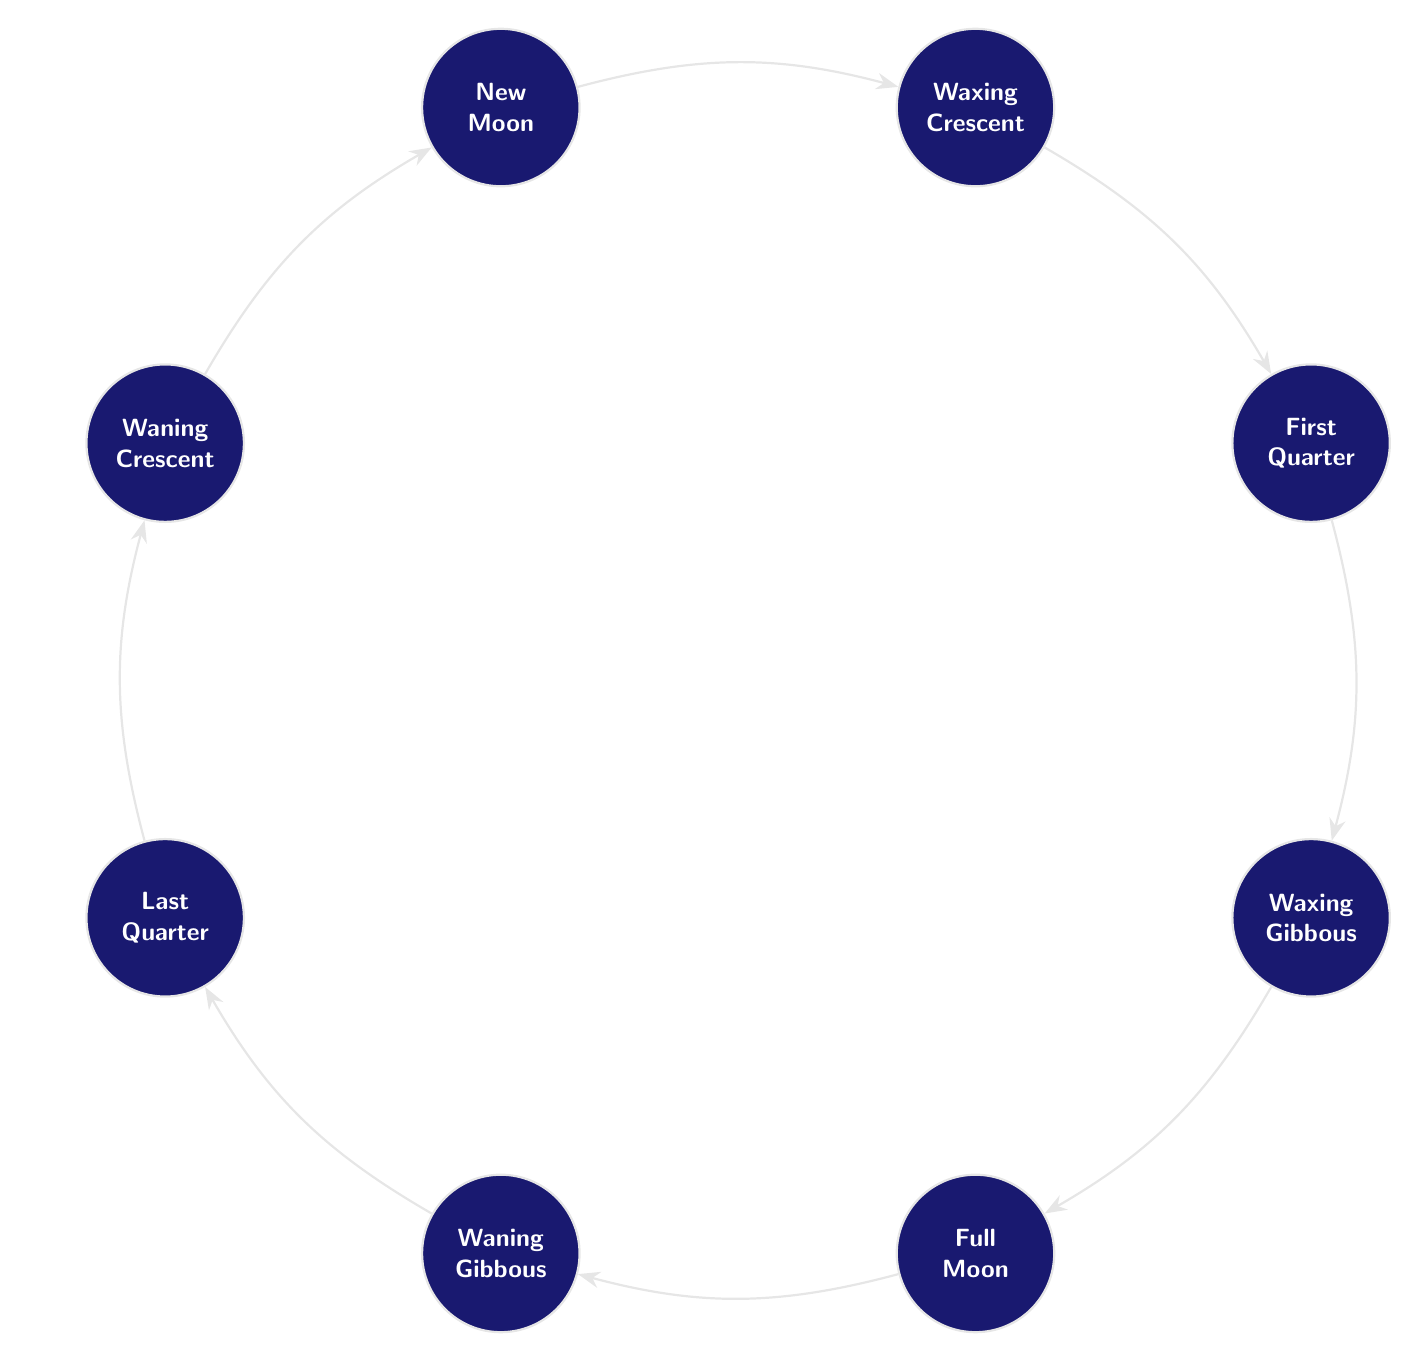What are the names of the phases of the moon shown in the diagram? The diagram displays several phases of the moon including New Moon, Waxing Crescent, First Quarter, Waxing Gibbous, Full Moon, Waning Gibbous, Last Quarter, and Waning Crescent.
Answer: New Moon, Waxing Crescent, First Quarter, Waxing Gibbous, Full Moon, Waning Gibbous, Last Quarter, Waning Crescent How many phases of the moon are represented in the diagram? There are eight distinct phases of the moon represented in the diagram: New Moon, Waxing Crescent, First Quarter, Waxing Gibbous, Full Moon, Waning Gibbous, Last Quarter, and Waning Crescent.
Answer: Eight What phase of the moon comes directly after the New Moon? From the diagram, after the New Moon phase, the next phase in the sequence is the Waxing Crescent.
Answer: Waxing Crescent Which moon phase is positioned directly below the First Quarter? According to the layout of the diagram, the moon phase directly below the First Quarter is the Waxing Gibbous.
Answer: Waxing Gibbous What connection type is used between the moon phases in the diagram? The connection between the moon phases in the diagram is represented by arrows labeled with the style "Stealth," indicating the flow from one phase to the next.
Answer: Stealth If you start from the Full Moon, which phase is the next one in the sequence? Following the sequence presented in the diagram, starting from the Full Moon, the next phase is the Waning Gibbous.
Answer: Waning Gibbous Which two phases are directly opposite each other in the diagram? From the structure of the diagram, the phases that are directly opposite each other are the New Moon and the Full Moon.
Answer: New Moon, Full Moon What additional information is provided below the title in the diagram? The diagram provides a reflective statement regarding the connection of local inhabitants, particularly reminiscing about the now-closed Patrick County Hospital, and the significance of the moon's cycles to the community.
Answer: Reflection on local history and the changing community 